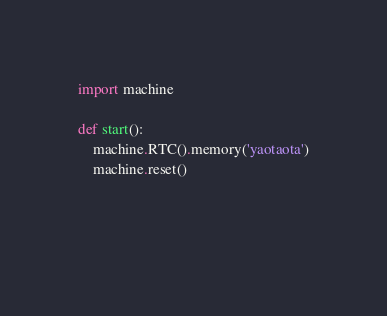Convert code to text. <code><loc_0><loc_0><loc_500><loc_500><_Python_>import machine

def start():
    machine.RTC().memory('yaotaota')
    machine.reset()
    
    
    </code> 